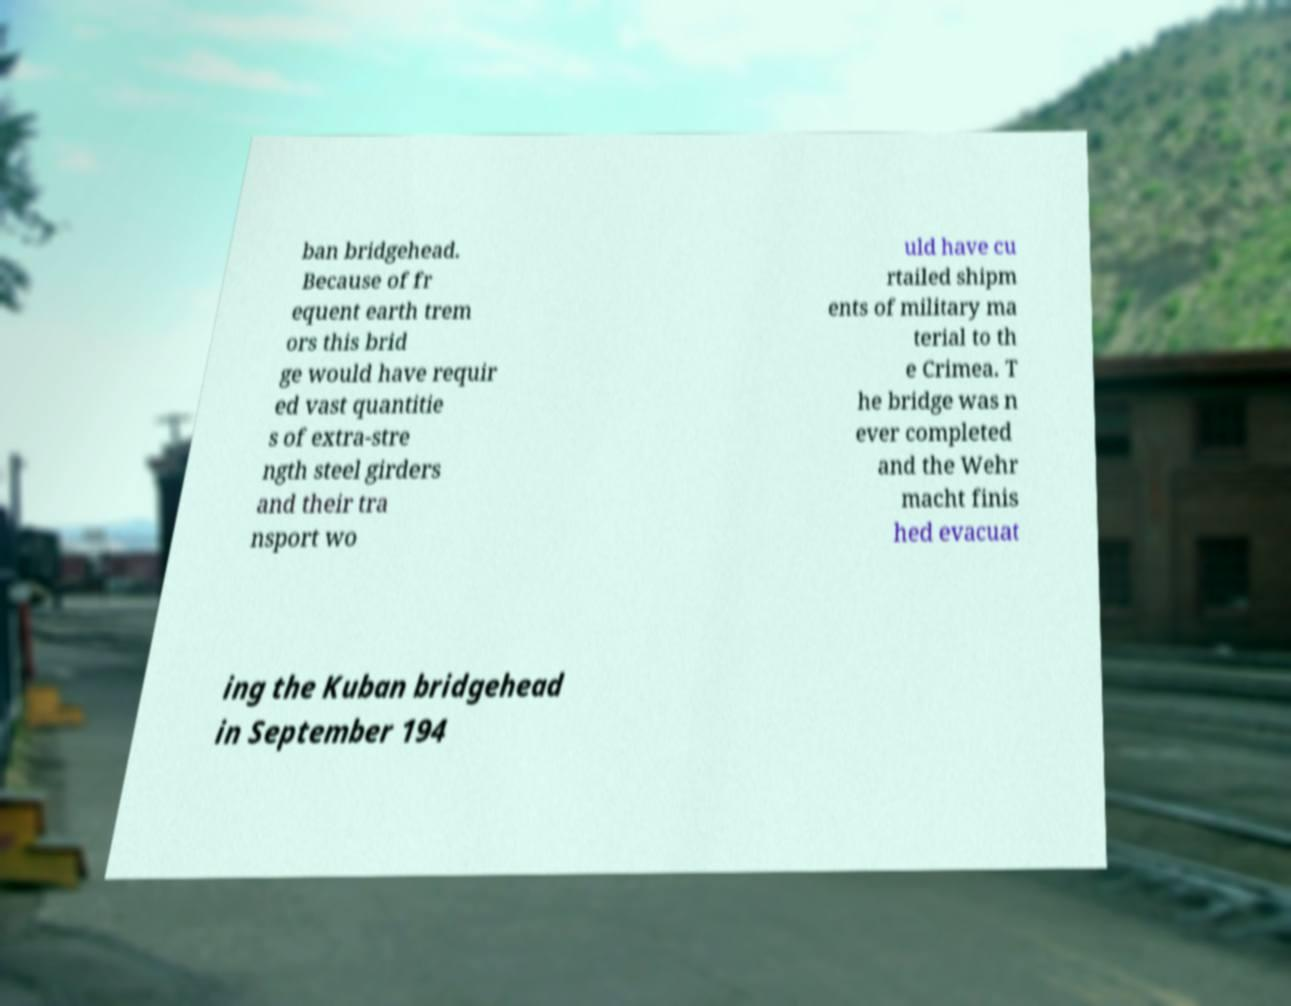Please identify and transcribe the text found in this image. ban bridgehead. Because of fr equent earth trem ors this brid ge would have requir ed vast quantitie s of extra-stre ngth steel girders and their tra nsport wo uld have cu rtailed shipm ents of military ma terial to th e Crimea. T he bridge was n ever completed and the Wehr macht finis hed evacuat ing the Kuban bridgehead in September 194 